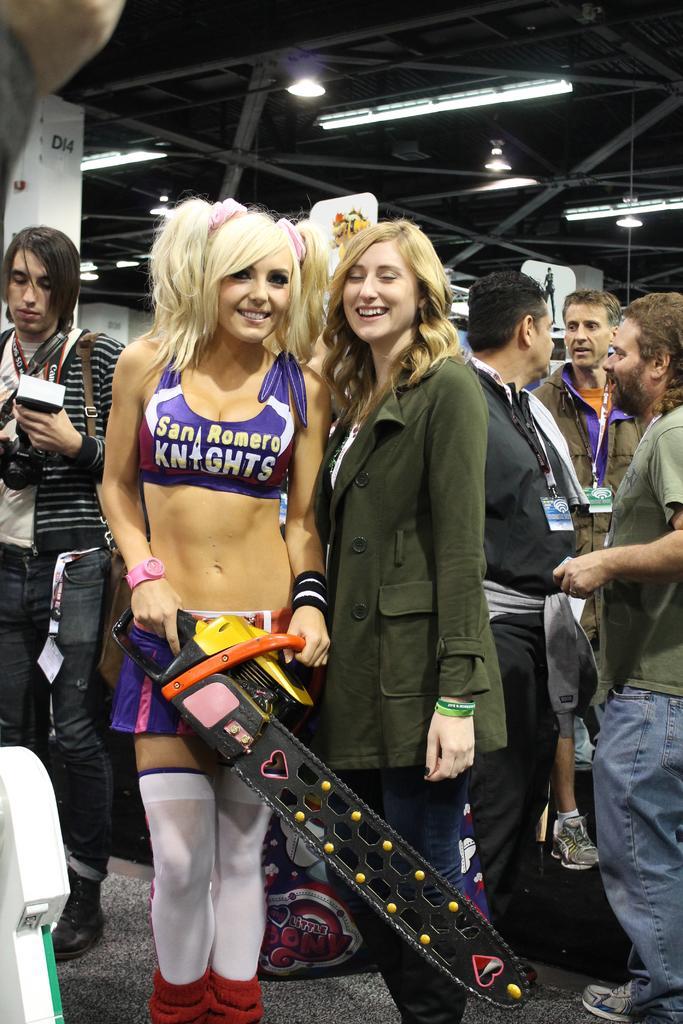Could you give a brief overview of what you see in this image? In this picture I can see few people standing and I can see they are wearing ID cards and I can see a woman holding a chainsaw blade in her hands and I can see lights on the ceiling and I can see a man and a camera. 